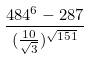<formula> <loc_0><loc_0><loc_500><loc_500>\frac { 4 8 4 ^ { 6 } - 2 8 7 } { ( \frac { 1 0 } { \sqrt { 3 } } ) ^ { \sqrt { 1 5 1 } } }</formula> 